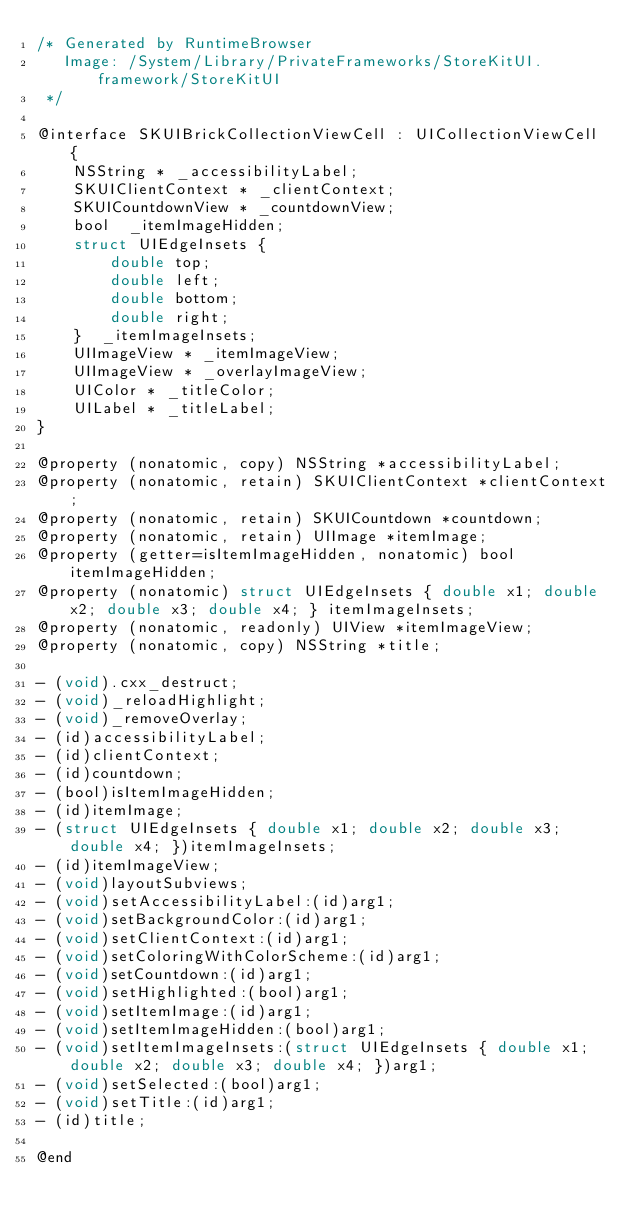<code> <loc_0><loc_0><loc_500><loc_500><_C_>/* Generated by RuntimeBrowser
   Image: /System/Library/PrivateFrameworks/StoreKitUI.framework/StoreKitUI
 */

@interface SKUIBrickCollectionViewCell : UICollectionViewCell {
    NSString * _accessibilityLabel;
    SKUIClientContext * _clientContext;
    SKUICountdownView * _countdownView;
    bool  _itemImageHidden;
    struct UIEdgeInsets { 
        double top; 
        double left; 
        double bottom; 
        double right; 
    }  _itemImageInsets;
    UIImageView * _itemImageView;
    UIImageView * _overlayImageView;
    UIColor * _titleColor;
    UILabel * _titleLabel;
}

@property (nonatomic, copy) NSString *accessibilityLabel;
@property (nonatomic, retain) SKUIClientContext *clientContext;
@property (nonatomic, retain) SKUICountdown *countdown;
@property (nonatomic, retain) UIImage *itemImage;
@property (getter=isItemImageHidden, nonatomic) bool itemImageHidden;
@property (nonatomic) struct UIEdgeInsets { double x1; double x2; double x3; double x4; } itemImageInsets;
@property (nonatomic, readonly) UIView *itemImageView;
@property (nonatomic, copy) NSString *title;

- (void).cxx_destruct;
- (void)_reloadHighlight;
- (void)_removeOverlay;
- (id)accessibilityLabel;
- (id)clientContext;
- (id)countdown;
- (bool)isItemImageHidden;
- (id)itemImage;
- (struct UIEdgeInsets { double x1; double x2; double x3; double x4; })itemImageInsets;
- (id)itemImageView;
- (void)layoutSubviews;
- (void)setAccessibilityLabel:(id)arg1;
- (void)setBackgroundColor:(id)arg1;
- (void)setClientContext:(id)arg1;
- (void)setColoringWithColorScheme:(id)arg1;
- (void)setCountdown:(id)arg1;
- (void)setHighlighted:(bool)arg1;
- (void)setItemImage:(id)arg1;
- (void)setItemImageHidden:(bool)arg1;
- (void)setItemImageInsets:(struct UIEdgeInsets { double x1; double x2; double x3; double x4; })arg1;
- (void)setSelected:(bool)arg1;
- (void)setTitle:(id)arg1;
- (id)title;

@end
</code> 